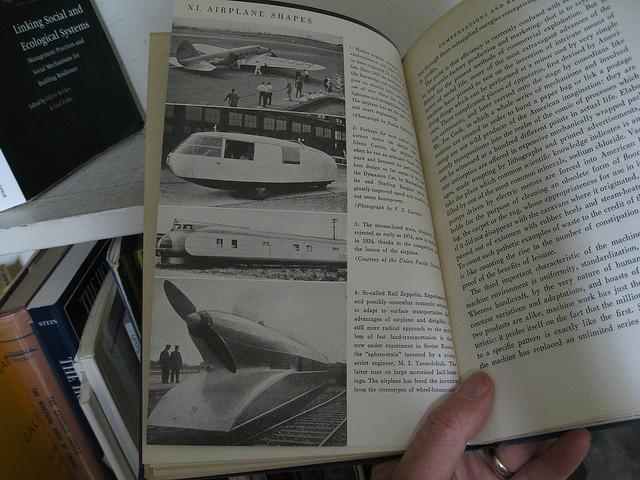What kind of object is to the front of this strange train?
Select the accurate answer and provide explanation: 'Answer: answer
Rationale: rationale.'
Options: Smokestack, propeller, face, engine. Answer: propeller.
Rationale: The object is a propeller. 